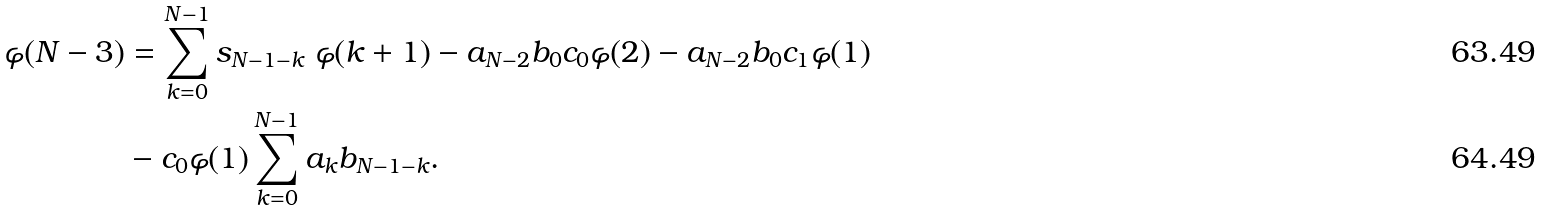Convert formula to latex. <formula><loc_0><loc_0><loc_500><loc_500>\varphi ( N - 3 ) & = \sum _ { k = 0 } ^ { N - 1 } s _ { N - 1 - k } \ \varphi ( k + 1 ) - a _ { N - 2 } b _ { 0 } c _ { 0 } \varphi ( 2 ) - a _ { N - 2 } b _ { 0 } c _ { 1 } \varphi ( 1 ) \\ & - c _ { 0 } \varphi ( 1 ) \sum _ { k = 0 } ^ { N - 1 } a _ { k } b _ { N - 1 - k } .</formula> 